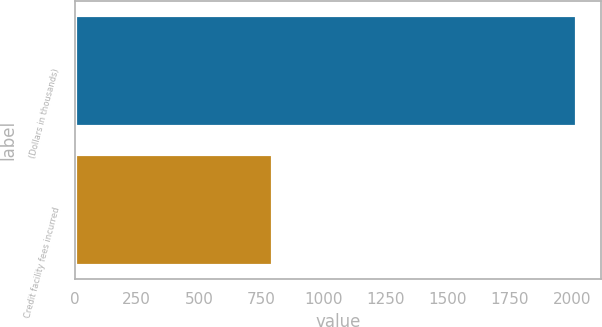Convert chart. <chart><loc_0><loc_0><loc_500><loc_500><bar_chart><fcel>(Dollars in thousands)<fcel>Credit facility fees incurred<nl><fcel>2016<fcel>793<nl></chart> 